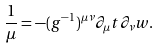Convert formula to latex. <formula><loc_0><loc_0><loc_500><loc_500>\frac { 1 } { \mu } = - ( g ^ { - 1 } ) ^ { \mu \nu } \partial _ { \mu } t \partial _ { \nu } w .</formula> 